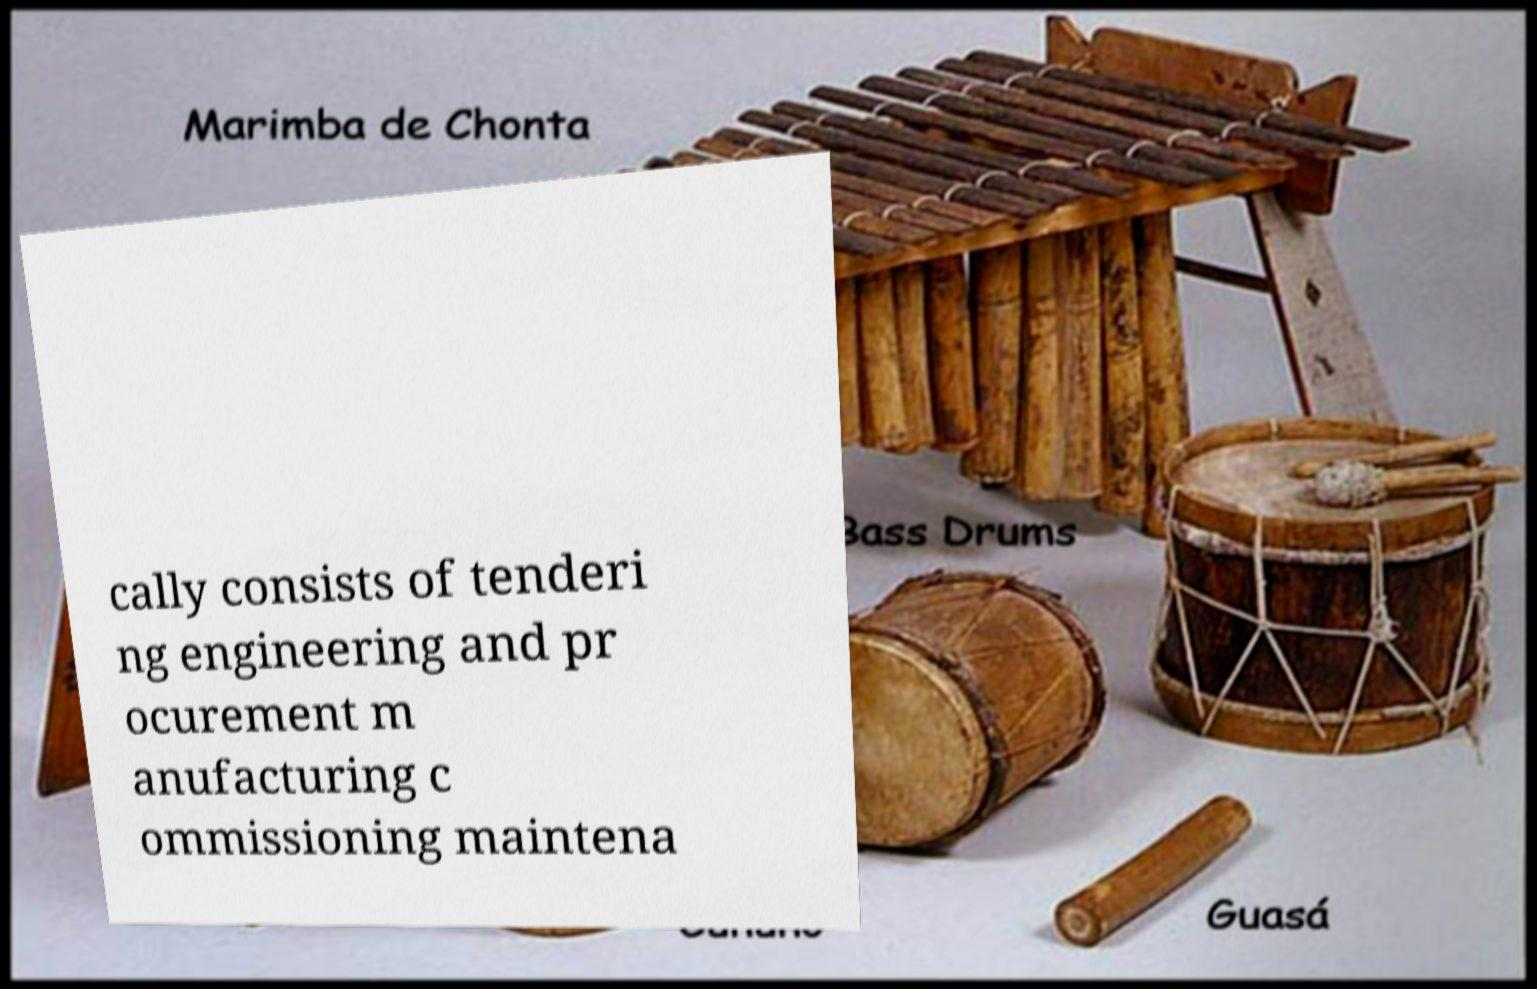Please read and relay the text visible in this image. What does it say? cally consists of tenderi ng engineering and pr ocurement m anufacturing c ommissioning maintena 